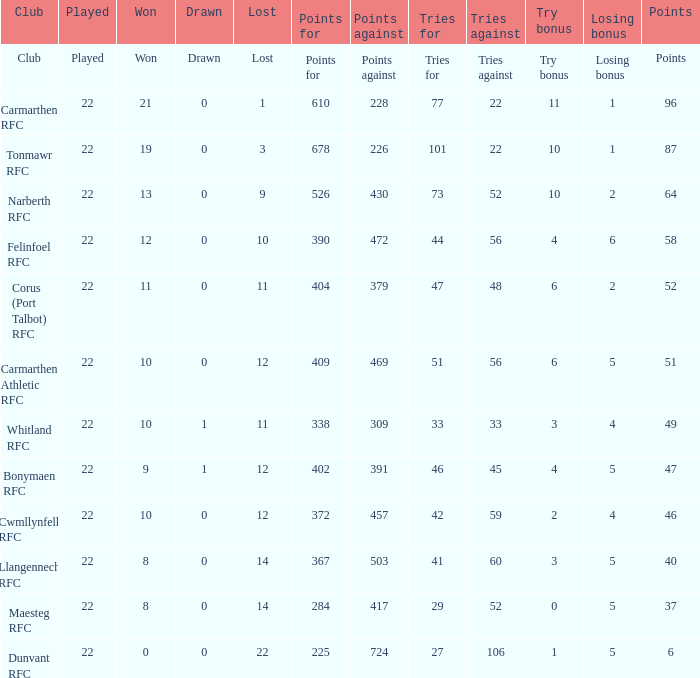Name the points against for 51 points 469.0. 